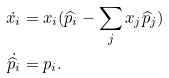Convert formula to latex. <formula><loc_0><loc_0><loc_500><loc_500>\dot { x _ { i } } & = x _ { i } ( \widehat { p } _ { i } - \sum _ { j } x _ { j } \widehat { p } _ { j } ) \\ \dot { \widehat { p } _ { i } } & = p _ { i } .</formula> 